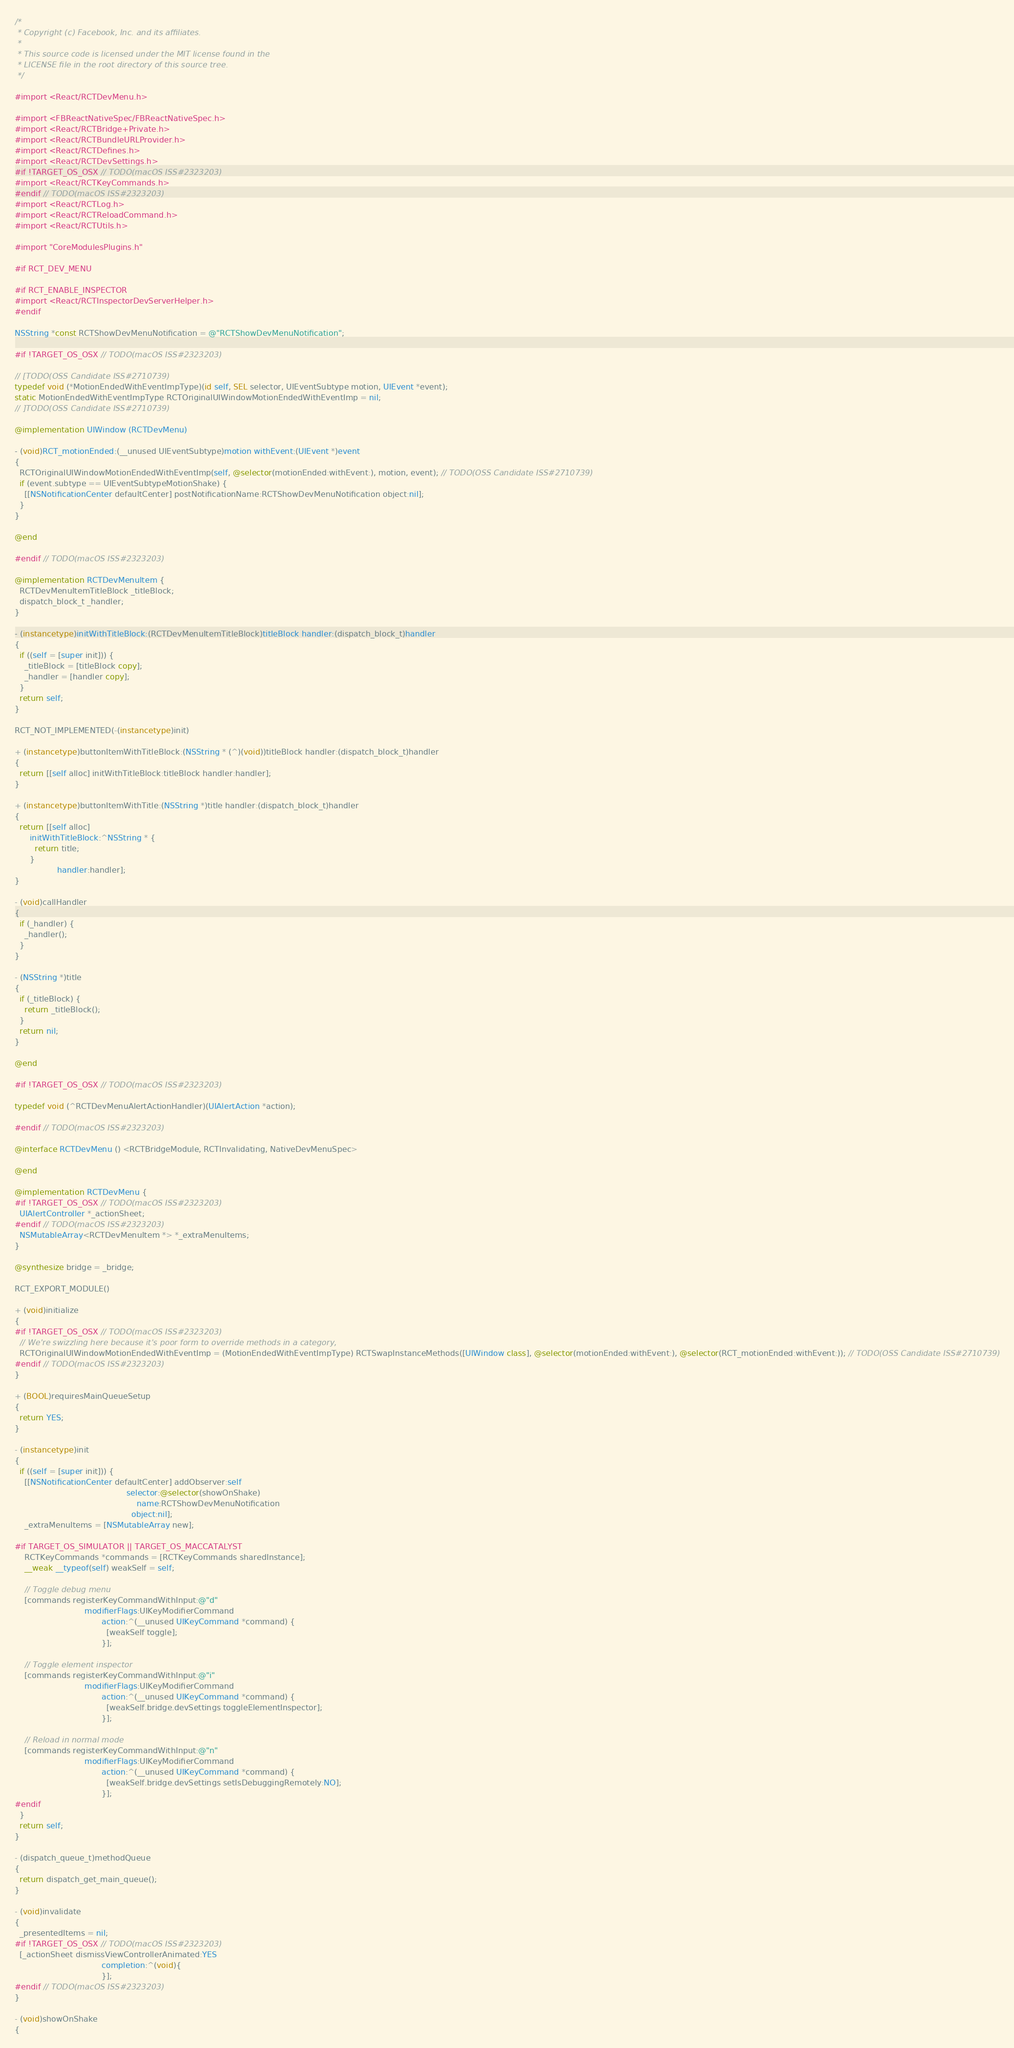<code> <loc_0><loc_0><loc_500><loc_500><_ObjectiveC_>/*
 * Copyright (c) Facebook, Inc. and its affiliates.
 *
 * This source code is licensed under the MIT license found in the
 * LICENSE file in the root directory of this source tree.
 */

#import <React/RCTDevMenu.h>

#import <FBReactNativeSpec/FBReactNativeSpec.h>
#import <React/RCTBridge+Private.h>
#import <React/RCTBundleURLProvider.h>
#import <React/RCTDefines.h>
#import <React/RCTDevSettings.h>
#if !TARGET_OS_OSX // TODO(macOS ISS#2323203)
#import <React/RCTKeyCommands.h>
#endif // TODO(macOS ISS#2323203)
#import <React/RCTLog.h>
#import <React/RCTReloadCommand.h>
#import <React/RCTUtils.h>

#import "CoreModulesPlugins.h"

#if RCT_DEV_MENU

#if RCT_ENABLE_INSPECTOR
#import <React/RCTInspectorDevServerHelper.h>
#endif

NSString *const RCTShowDevMenuNotification = @"RCTShowDevMenuNotification";

#if !TARGET_OS_OSX // TODO(macOS ISS#2323203)

// [TODO(OSS Candidate ISS#2710739)
typedef void (*MotionEndedWithEventImpType)(id self, SEL selector, UIEventSubtype motion, UIEvent *event);
static MotionEndedWithEventImpType RCTOriginalUIWindowMotionEndedWithEventImp = nil;
// ]TODO(OSS Candidate ISS#2710739)

@implementation UIWindow (RCTDevMenu)

- (void)RCT_motionEnded:(__unused UIEventSubtype)motion withEvent:(UIEvent *)event
{
  RCTOriginalUIWindowMotionEndedWithEventImp(self, @selector(motionEnded:withEvent:), motion, event); // TODO(OSS Candidate ISS#2710739)
  if (event.subtype == UIEventSubtypeMotionShake) {
    [[NSNotificationCenter defaultCenter] postNotificationName:RCTShowDevMenuNotification object:nil];
  }
}

@end

#endif // TODO(macOS ISS#2323203)

@implementation RCTDevMenuItem {
  RCTDevMenuItemTitleBlock _titleBlock;
  dispatch_block_t _handler;
}

- (instancetype)initWithTitleBlock:(RCTDevMenuItemTitleBlock)titleBlock handler:(dispatch_block_t)handler
{
  if ((self = [super init])) {
    _titleBlock = [titleBlock copy];
    _handler = [handler copy];
  }
  return self;
}

RCT_NOT_IMPLEMENTED(-(instancetype)init)

+ (instancetype)buttonItemWithTitleBlock:(NSString * (^)(void))titleBlock handler:(dispatch_block_t)handler
{
  return [[self alloc] initWithTitleBlock:titleBlock handler:handler];
}

+ (instancetype)buttonItemWithTitle:(NSString *)title handler:(dispatch_block_t)handler
{
  return [[self alloc]
      initWithTitleBlock:^NSString * {
        return title;
      }
                 handler:handler];
}

- (void)callHandler
{
  if (_handler) {
    _handler();
  }
}

- (NSString *)title
{
  if (_titleBlock) {
    return _titleBlock();
  }
  return nil;
}

@end

#if !TARGET_OS_OSX // TODO(macOS ISS#2323203)

typedef void (^RCTDevMenuAlertActionHandler)(UIAlertAction *action);

#endif // TODO(macOS ISS#2323203)

@interface RCTDevMenu () <RCTBridgeModule, RCTInvalidating, NativeDevMenuSpec>

@end

@implementation RCTDevMenu {
#if !TARGET_OS_OSX // TODO(macOS ISS#2323203)
  UIAlertController *_actionSheet;
#endif // TODO(macOS ISS#2323203)
  NSMutableArray<RCTDevMenuItem *> *_extraMenuItems;
}

@synthesize bridge = _bridge;

RCT_EXPORT_MODULE()

+ (void)initialize
{
#if !TARGET_OS_OSX // TODO(macOS ISS#2323203)
  // We're swizzling here because it's poor form to override methods in a category,
  RCTOriginalUIWindowMotionEndedWithEventImp = (MotionEndedWithEventImpType) RCTSwapInstanceMethods([UIWindow class], @selector(motionEnded:withEvent:), @selector(RCT_motionEnded:withEvent:)); // TODO(OSS Candidate ISS#2710739)
#endif // TODO(macOS ISS#2323203)
}

+ (BOOL)requiresMainQueueSetup
{
  return YES;
}

- (instancetype)init
{
  if ((self = [super init])) {
    [[NSNotificationCenter defaultCenter] addObserver:self
                                             selector:@selector(showOnShake)
                                                 name:RCTShowDevMenuNotification
                                               object:nil];
    _extraMenuItems = [NSMutableArray new];

#if TARGET_OS_SIMULATOR || TARGET_OS_MACCATALYST
    RCTKeyCommands *commands = [RCTKeyCommands sharedInstance];
    __weak __typeof(self) weakSelf = self;

    // Toggle debug menu
    [commands registerKeyCommandWithInput:@"d"
                            modifierFlags:UIKeyModifierCommand
                                   action:^(__unused UIKeyCommand *command) {
                                     [weakSelf toggle];
                                   }];

    // Toggle element inspector
    [commands registerKeyCommandWithInput:@"i"
                            modifierFlags:UIKeyModifierCommand
                                   action:^(__unused UIKeyCommand *command) {
                                     [weakSelf.bridge.devSettings toggleElementInspector];
                                   }];

    // Reload in normal mode
    [commands registerKeyCommandWithInput:@"n"
                            modifierFlags:UIKeyModifierCommand
                                   action:^(__unused UIKeyCommand *command) {
                                     [weakSelf.bridge.devSettings setIsDebuggingRemotely:NO];
                                   }];
#endif
  }
  return self;
}

- (dispatch_queue_t)methodQueue
{
  return dispatch_get_main_queue();
}

- (void)invalidate
{
  _presentedItems = nil;
#if !TARGET_OS_OSX // TODO(macOS ISS#2323203)
  [_actionSheet dismissViewControllerAnimated:YES
                                   completion:^(void){
                                   }];
#endif // TODO(macOS ISS#2323203)
}

- (void)showOnShake
{</code> 